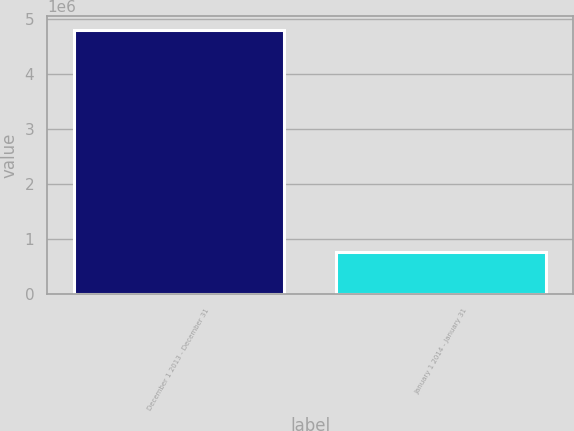<chart> <loc_0><loc_0><loc_500><loc_500><bar_chart><fcel>December 1 2013 - December 31<fcel>January 1 2014 - January 31<nl><fcel>4.80628e+06<fcel>768459<nl></chart> 